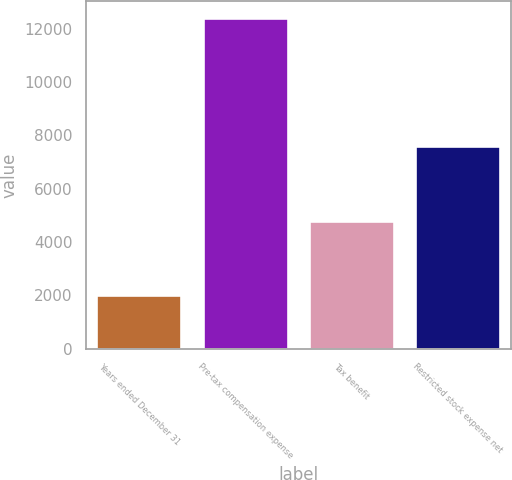Convert chart to OTSL. <chart><loc_0><loc_0><loc_500><loc_500><bar_chart><fcel>Years ended December 31<fcel>Pre-tax compensation expense<fcel>Tax benefit<fcel>Restricted stock expense net<nl><fcel>2016<fcel>12415<fcel>4805<fcel>7610<nl></chart> 